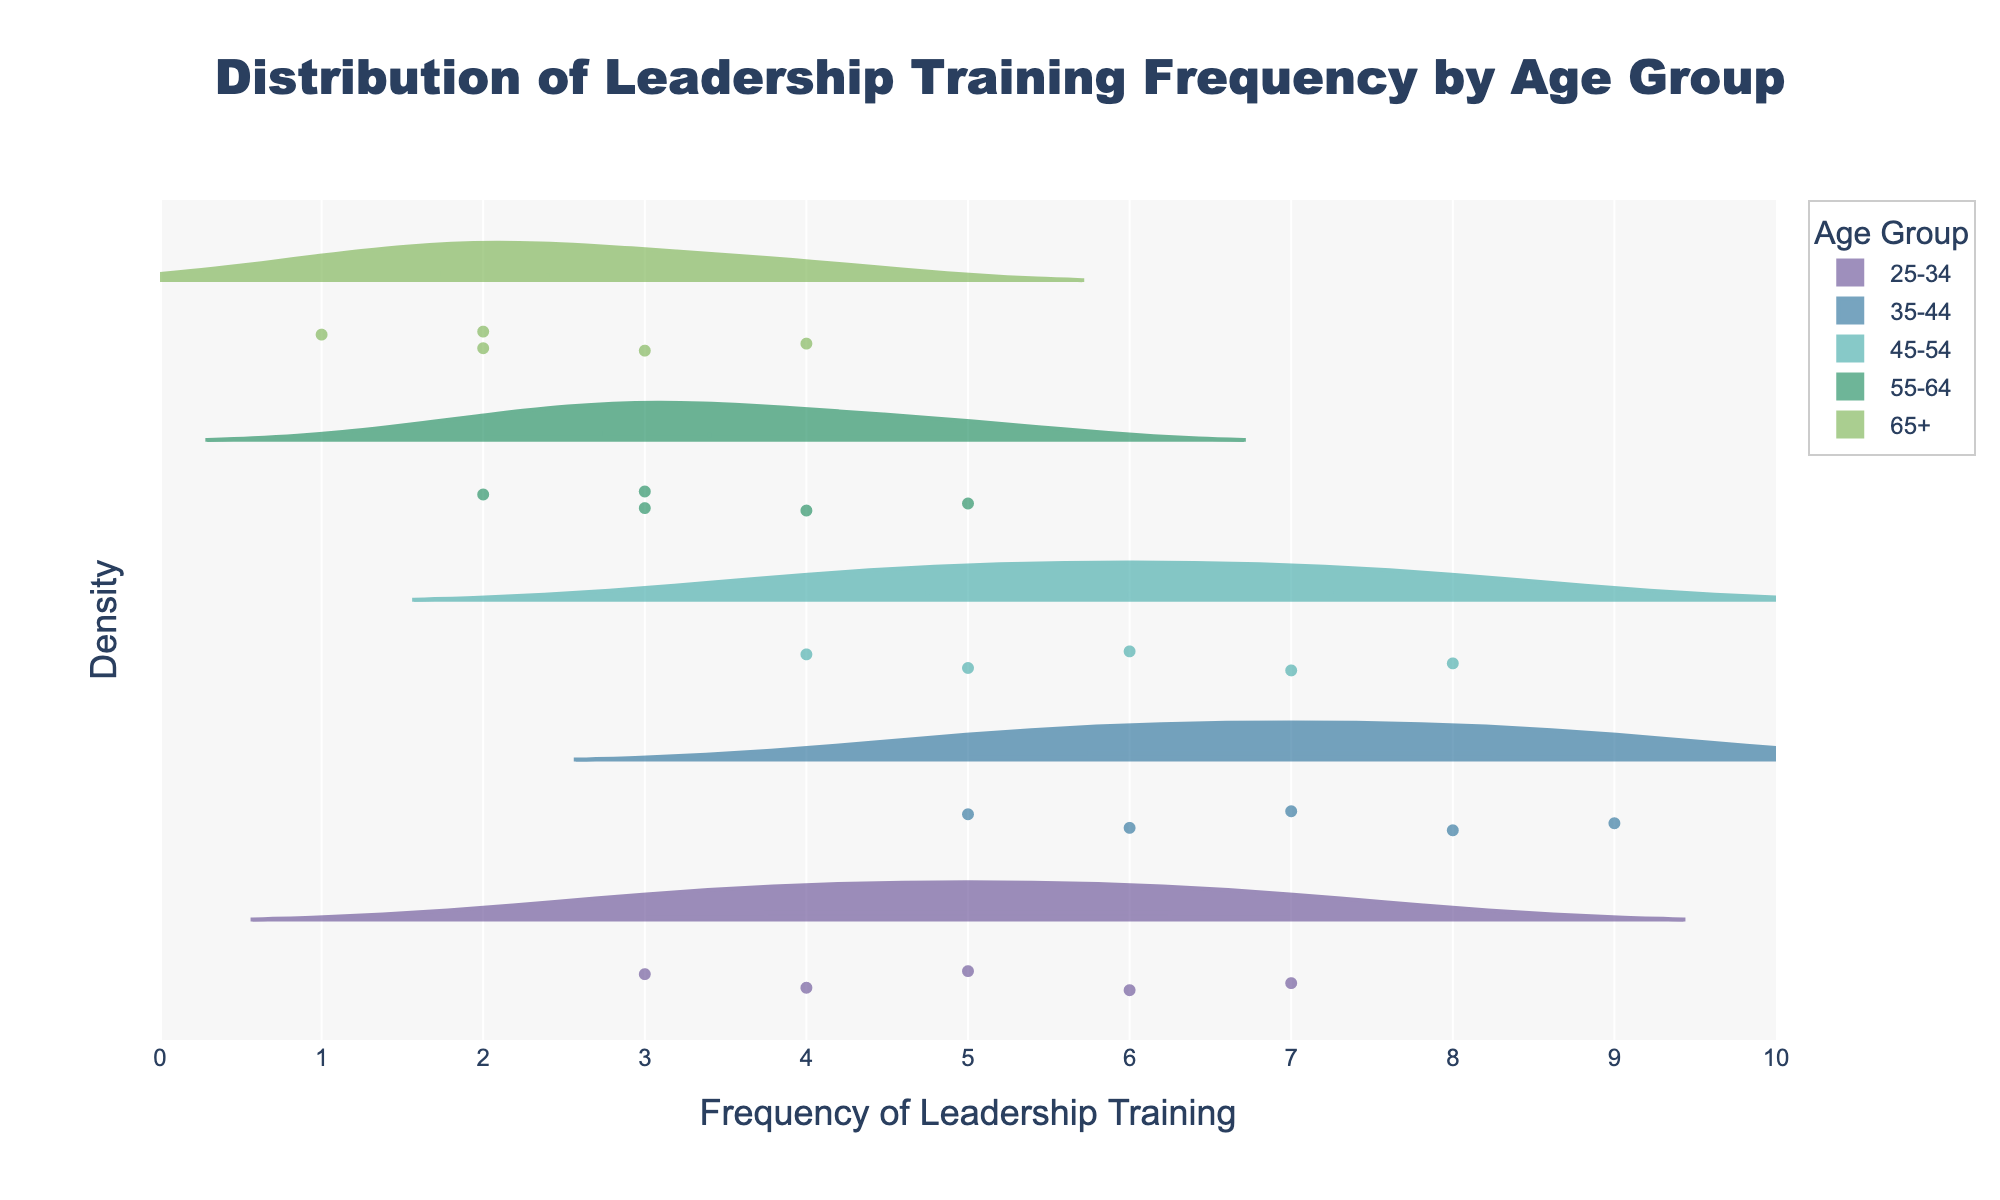What's the title of the plot? The title is located at the top center of the plot. It reads "Distribution of Leadership Training Frequency by Age Group".
Answer: Distribution of Leadership Training Frequency by Age Group What is the range of the x-axis in the plot? The x-axis range is defined at the base of the plot and spans from 0 to 10, as indicated by the tick marks and axis labels.
Answer: 0 to 10 How many data points are there in the 25-34 age group? By examining the distribution marked by points within the 25-34 age group's violin plot, we can count that there are 5 data points.
Answer: 5 Which age group has the highest median frequency of leadership training participation? Observe the median line (visible in the center of the violin plot) for each age group. The age group 35-44 has the highest median line which is around 7.
Answer: 35-44 Which age group shows the widest spread in leadership training participation? The spread can be identified by looking at the width of the violin plot. The 65+ age group has the widest spread, spanning from 1 to 4.
Answer: 65+ What is the average frequency of leadership training for the age group 45-54? Sum the frequencies for the 45-54 age group (6+5+4+7+8 = 30) and divide by the number of data points (5). Therefore, 30/5 = 6.
Answer: 6 Is there an age group that has a minimum frequency of 1? Locate the minimum values for each violin plot; the age group 65+ contains a minimum value of 1.
Answer: Yes, age group 65+ How does the maximum frequency of the age group 35-44 compare to that of 25-34? Determine the highest point on the violin plot for each group: 35-44 has a maximum frequency of 9, while 25-34 has a maximum frequency of 7.
Answer: 35-44 is greater Do any age groups have overlapping frequency distributions? By inspecting the width and placement of each violin plot, the age groups 45-54 and 35-44 show overlapping distributions mostly between the frequencies from 5 to 7.
Answer: Yes, 45-54 and 35-44 Which age group has the smallest variation in leadership training participation? The smallest variation can be found by comparing the range and spread of the violin plots; the age group 55-64 spans only from 2 to 5, showing the smallest variation.
Answer: 55-64 